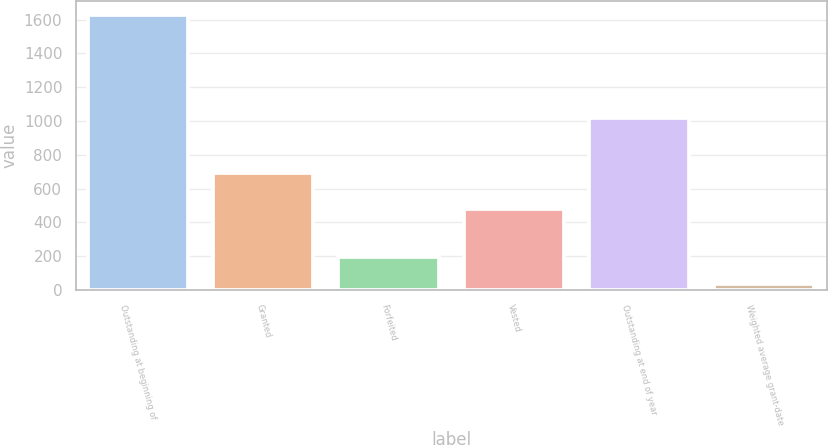<chart> <loc_0><loc_0><loc_500><loc_500><bar_chart><fcel>Outstanding at beginning of<fcel>Granted<fcel>Forfeited<fcel>Vested<fcel>Outstanding at end of year<fcel>Weighted average grant-date<nl><fcel>1627<fcel>695<fcel>195.23<fcel>477<fcel>1019<fcel>36.14<nl></chart> 